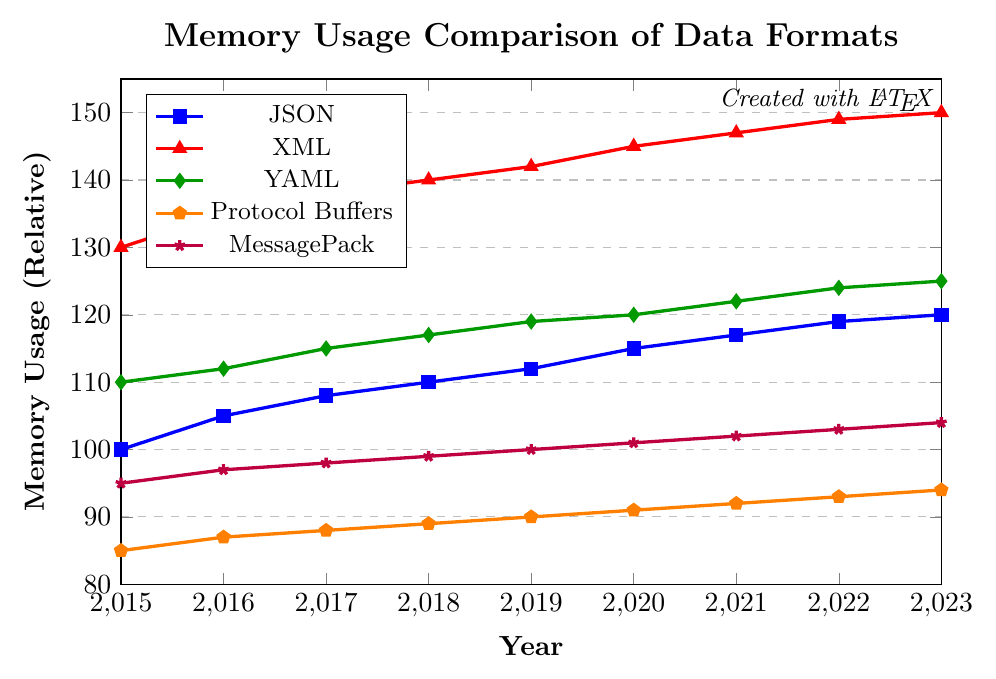What was the memory usage of JSON and XML in 2020? Look at the 2020 data points on the respective lines for JSON (blue squares) and XML (red triangles). JSON is at 115 and XML is at 145.
Answer: JSON: 115, XML: 145 Which data format had the lowest memory usage in 2016? To find the lowest memory usage in 2016, compare the data points for all formats in that year. JSON is at 105, XML at 135, YAML at 112, Protocol Buffers at 87, and MessagePack at 97. The lowest value is for Protocol Buffers at 87.
Answer: Protocol Buffers How did the memory usage of YAML change from 2017 to 2018? Look at the memory usage values of YAML (green diamonds) in 2017 and 2018. In 2017, YAML is at 115, and in 2018, it is at 117. Calculate the change: 117 - 115 = 2.
Answer: Increased by 2 What is the average memory usage of JSON from 2015 to 2023? Sum the memory usage values of JSON from 2015 to 2023 and divide by the number of years. (100 + 105 + 108 + 110 + 112 + 115 + 117 + 119 + 120) / 9 = 106.2222.
Answer: 106.2222 Which data format showed the highest increase in memory usage from 2015 to 2023? Calculate the increase for each format by subtracting the 2015 value from the 2023 value: JSON: 120-100=20, XML: 150-130=20, YAML: 125-110=15, Protocol Buffers: 94-85=9, MessagePack: 104-95=9. Both JSON and XML increased by 20.
Answer: JSON and XML Compare the relative slopes of the trend lines for XML and Protocol Buffers. Which has a steeper slope? To compare slopes, observe how quickly each line rises over the same period. XML (red triangles) rapidly increases from 130 to 150, while Protocol Buffers (orange pentagons) slowly increases from 85 to 94. XML’s slope is steeper.
Answer: XML In 2019, how much more memory did XML use compared to MessagePack? Look at the 2019 points for XML (red triangles) and MessagePack (purple stars). XML is at 142, and MessagePack is at 100. The difference is 142 - 100 = 42.
Answer: 42 Which data format consistently had lower memory usage than JSON from 2015 to 2023? Scan the entire period to identify formats consistently below JSON (blue squares). Protocol Buffers (orange pentagons) and MessagePack (purple stars) are consistently lower.
Answer: Protocol Buffers and MessagePack Determine the median value of YAML's memory usage from 2015 to 2023. List the values for YAML (green diamonds) from 2015 to 2023: 110, 112, 115, 117, 119, 120, 122, 124, 125. The median is the middle value of an ordered list, which is 119.
Answer: 119 